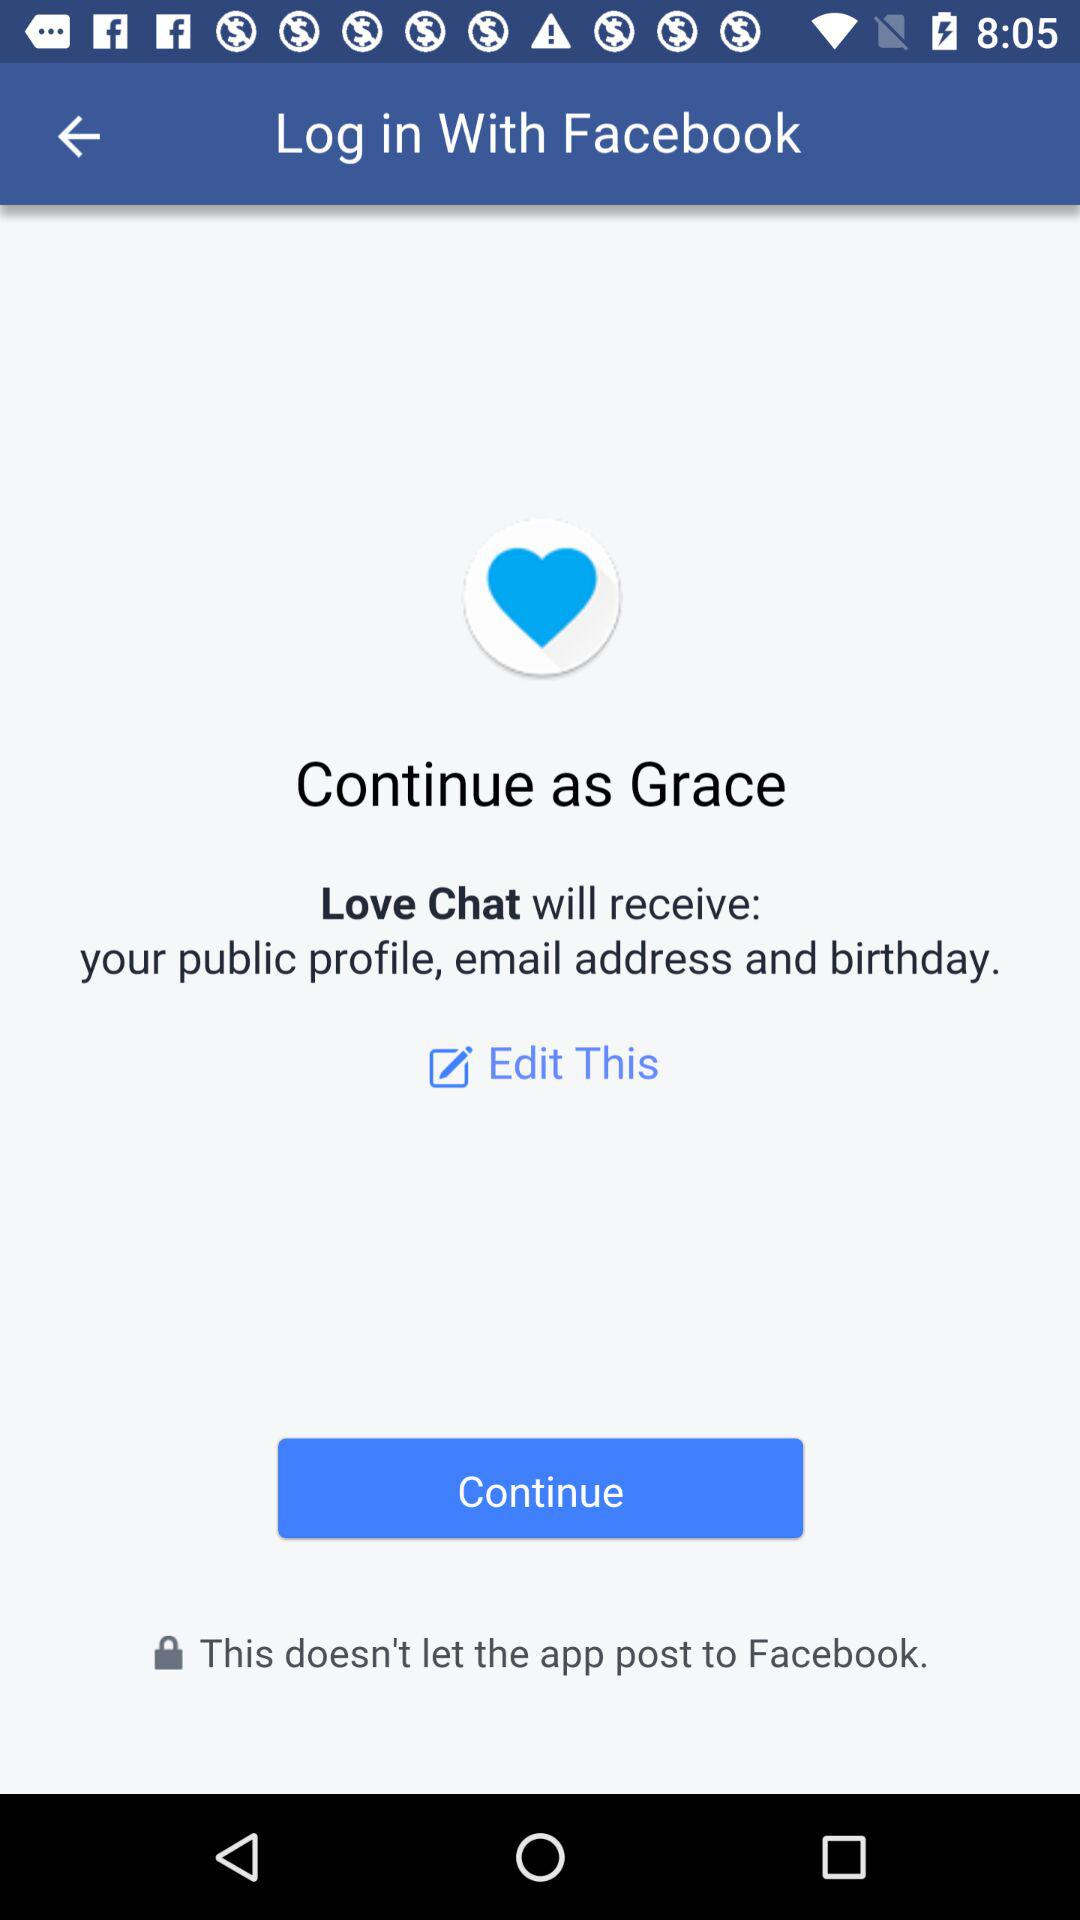What is the name of the user? The name of the user is Grace. 